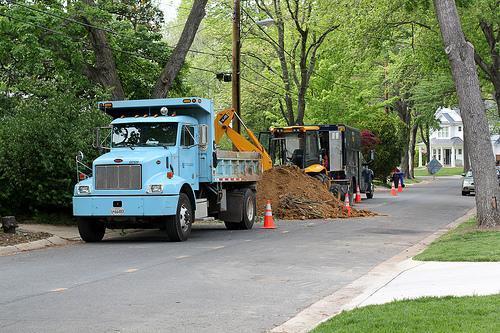How many safety cones are on ground?
Give a very brief answer. 5. 